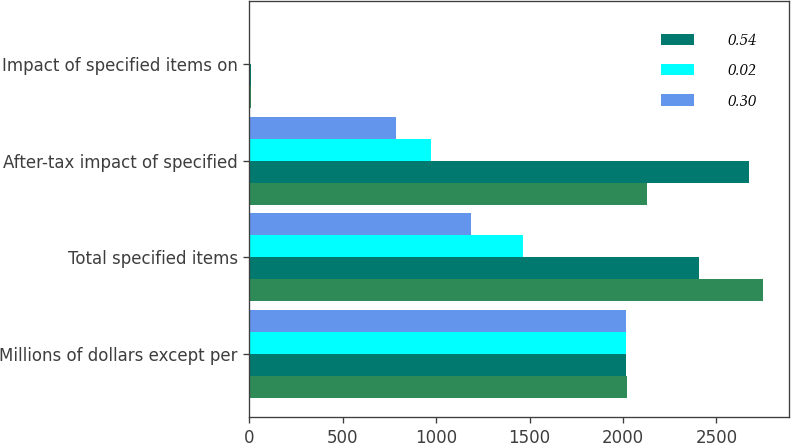<chart> <loc_0><loc_0><loc_500><loc_500><stacked_bar_chart><ecel><fcel>Millions of dollars except per<fcel>Total specified items<fcel>After-tax impact of specified<fcel>Impact of specified items on<nl><fcel>nan<fcel>2019<fcel>2749<fcel>2127<fcel>7.74<nl><fcel>0.54<fcel>2018<fcel>2409<fcel>2674<fcel>10.11<nl><fcel>0.02<fcel>2017<fcel>1466<fcel>971<fcel>4.34<nl><fcel>0.3<fcel>2015<fcel>1186<fcel>786<fcel>3.79<nl></chart> 